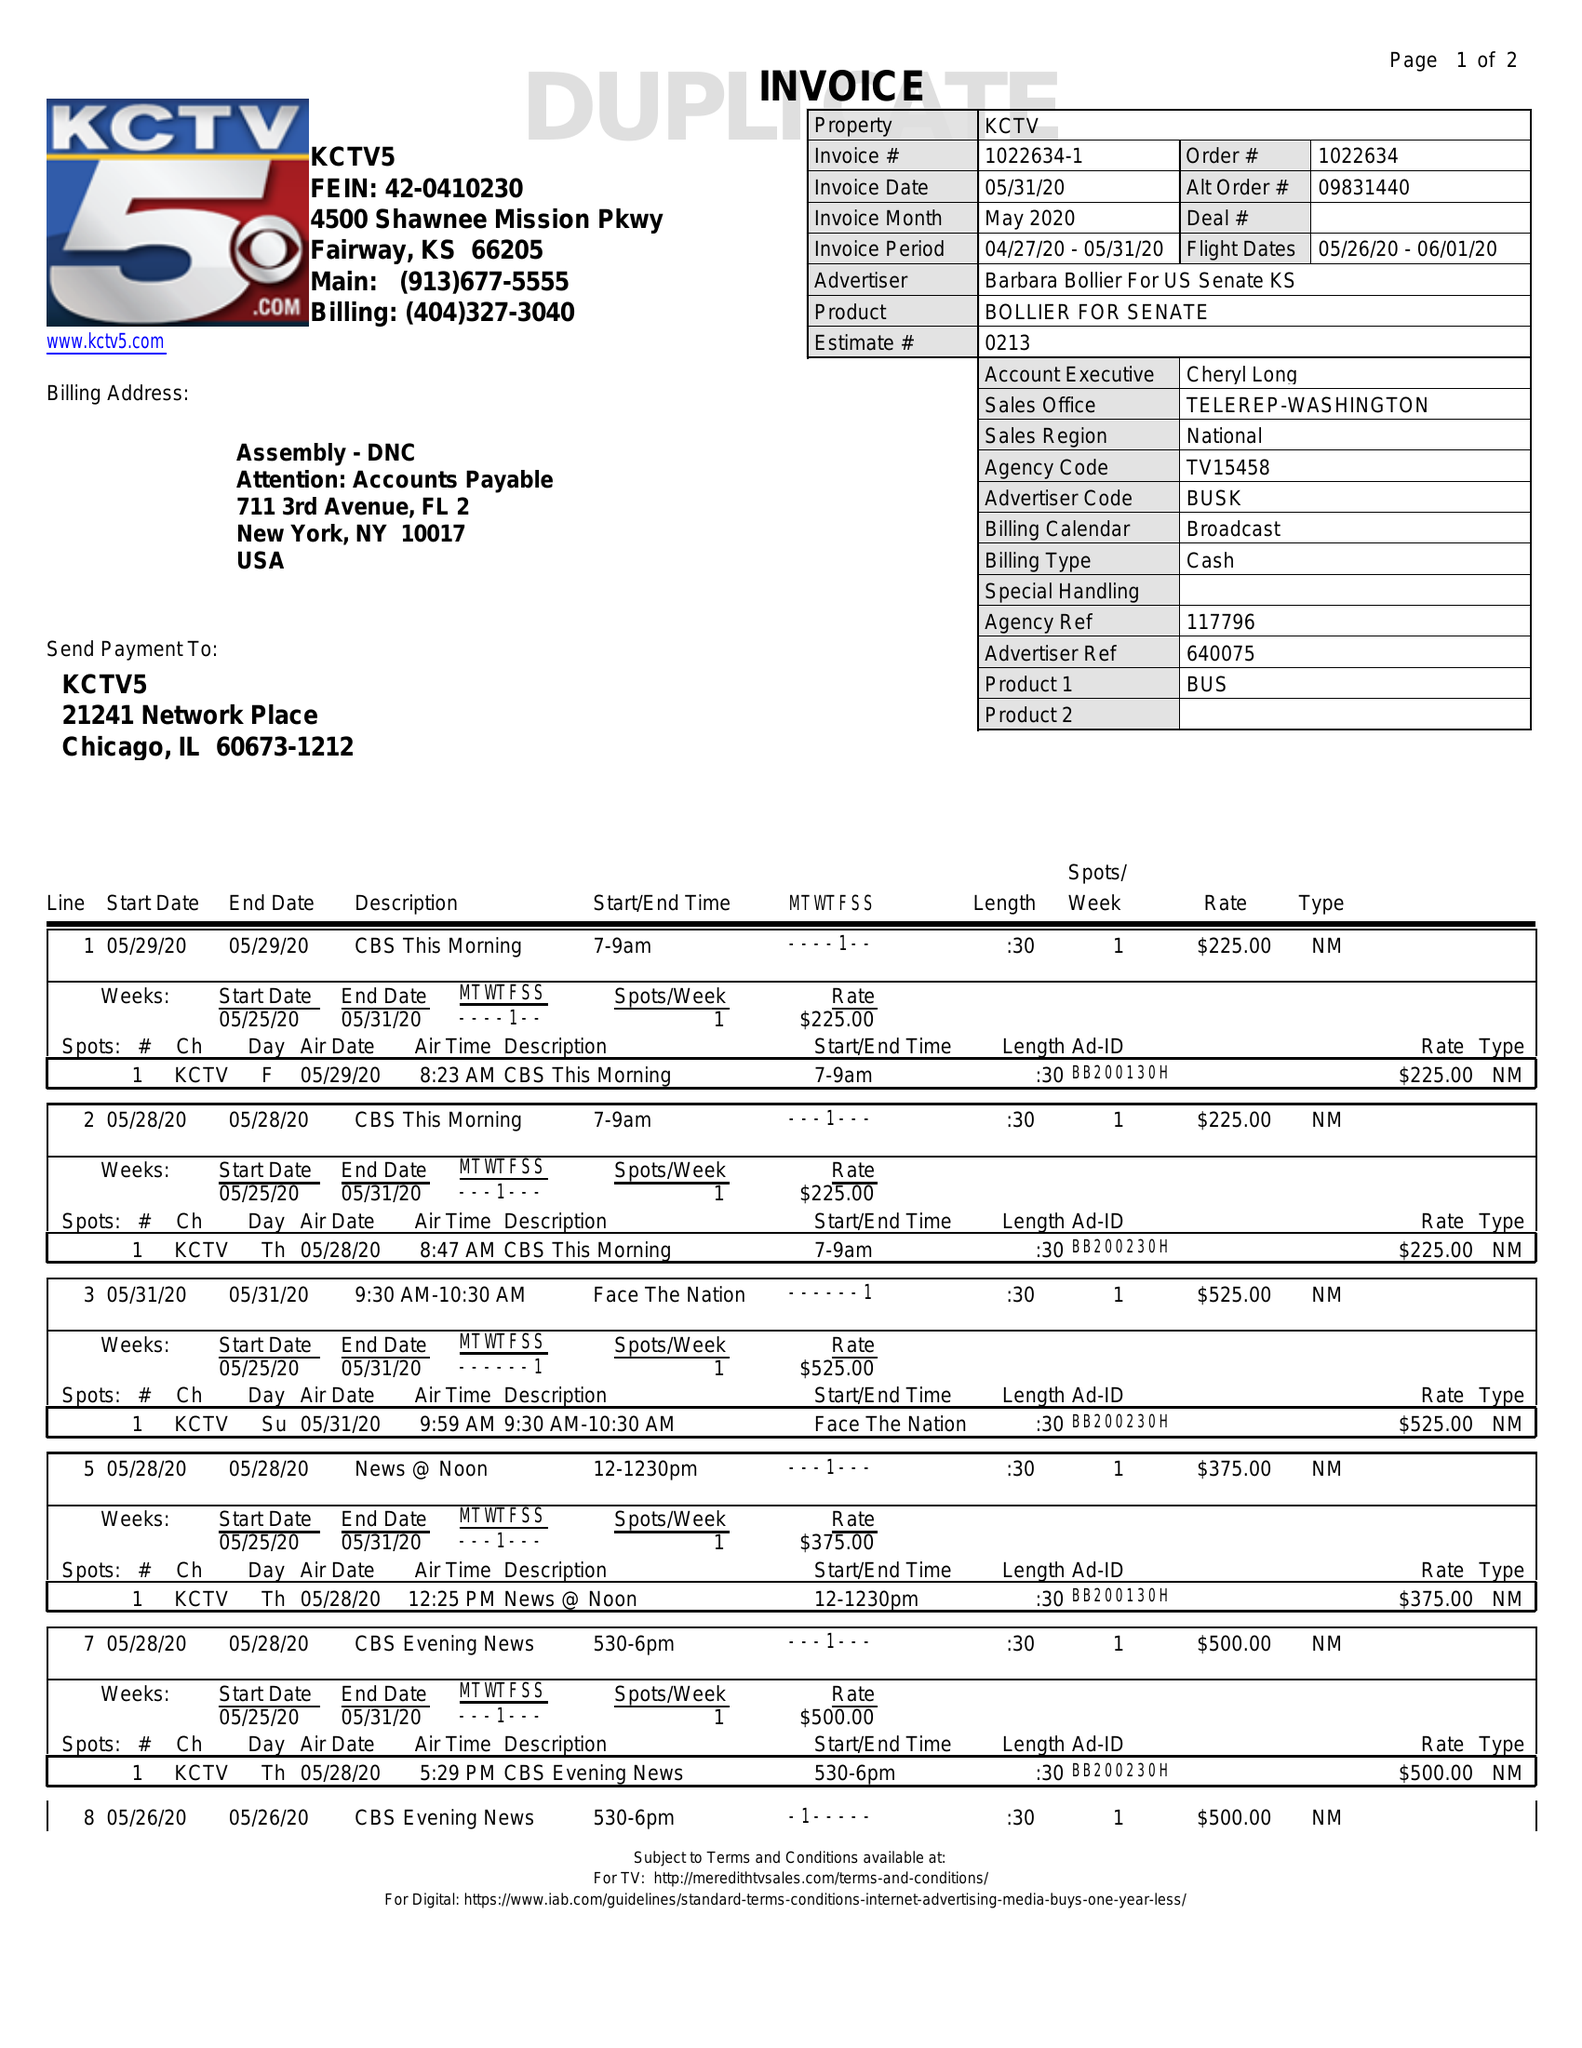What is the value for the flight_to?
Answer the question using a single word or phrase. 06/01/20 